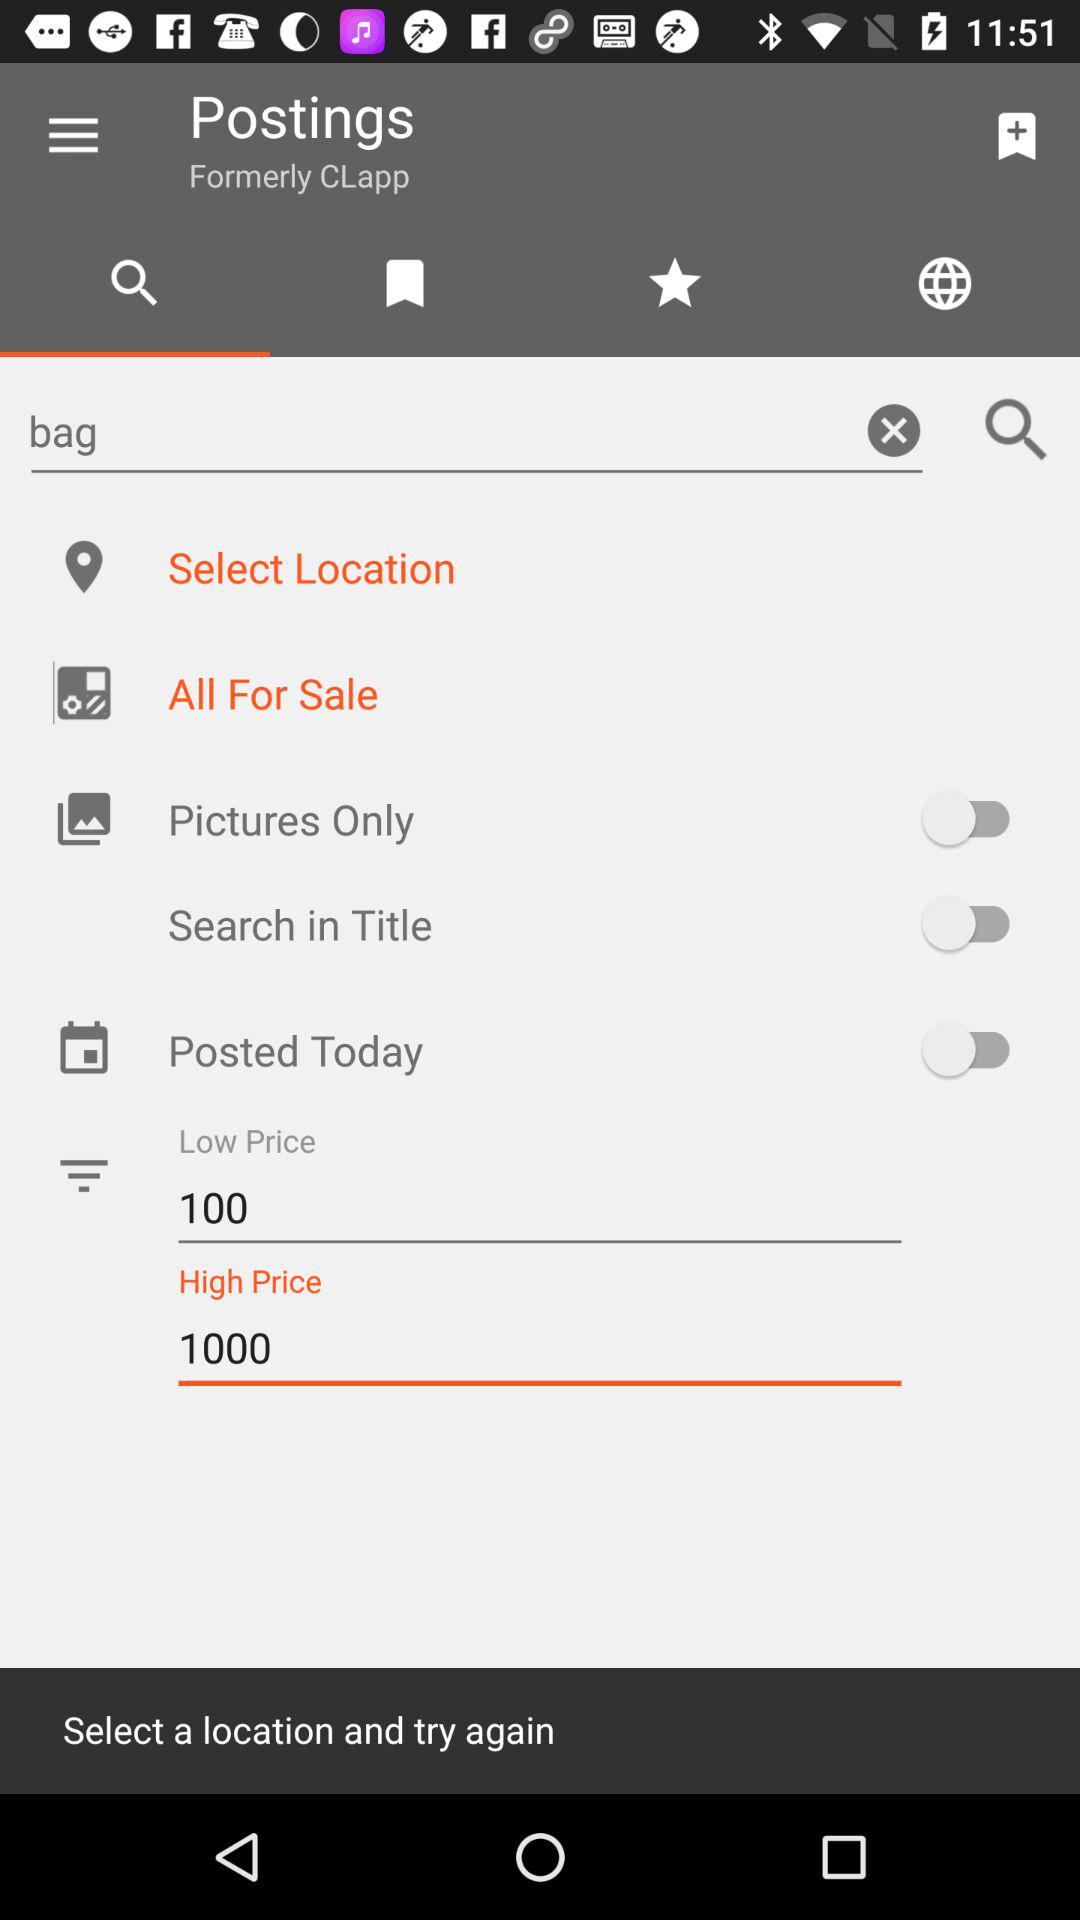What is the high price? The high price is 1000. 